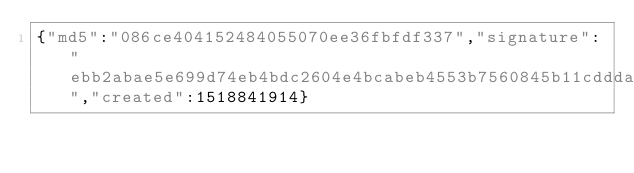Convert code to text. <code><loc_0><loc_0><loc_500><loc_500><_SML_>{"md5":"086ce404152484055070ee36fbfdf337","signature":"ebb2abae5e699d74eb4bdc2604e4bcabeb4553b7560845b11cdddaa364bf4d3b41a91414efb91687c2b8c319d0ca048c0e2d1f3d62b3ba144e9013677163210e","created":1518841914}</code> 